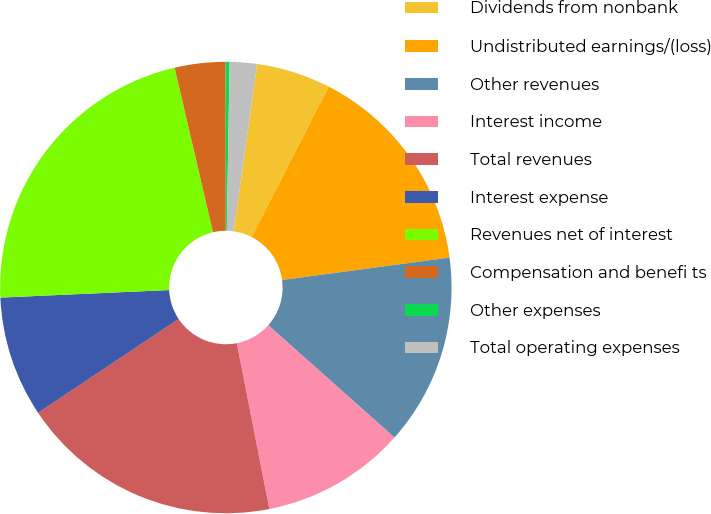Convert chart. <chart><loc_0><loc_0><loc_500><loc_500><pie_chart><fcel>Dividends from nonbank<fcel>Undistributed earnings/(loss)<fcel>Other revenues<fcel>Interest income<fcel>Total revenues<fcel>Interest expense<fcel>Revenues net of interest<fcel>Compensation and benefi ts<fcel>Other expenses<fcel>Total operating expenses<nl><fcel>5.31%<fcel>15.36%<fcel>13.69%<fcel>10.34%<fcel>18.72%<fcel>8.66%<fcel>22.07%<fcel>3.63%<fcel>0.28%<fcel>1.95%<nl></chart> 